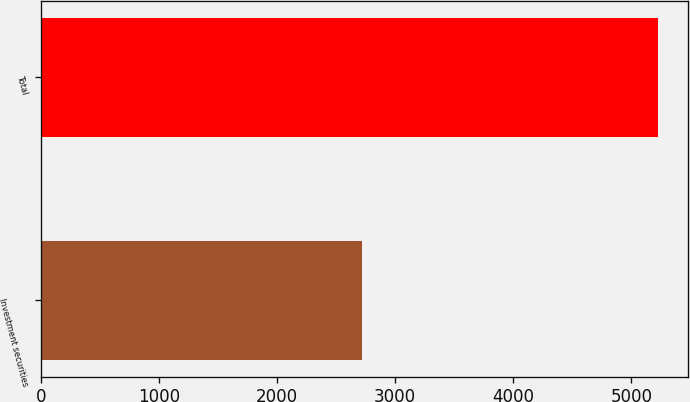Convert chart to OTSL. <chart><loc_0><loc_0><loc_500><loc_500><bar_chart><fcel>Investment securities<fcel>Total<nl><fcel>2721<fcel>5221<nl></chart> 